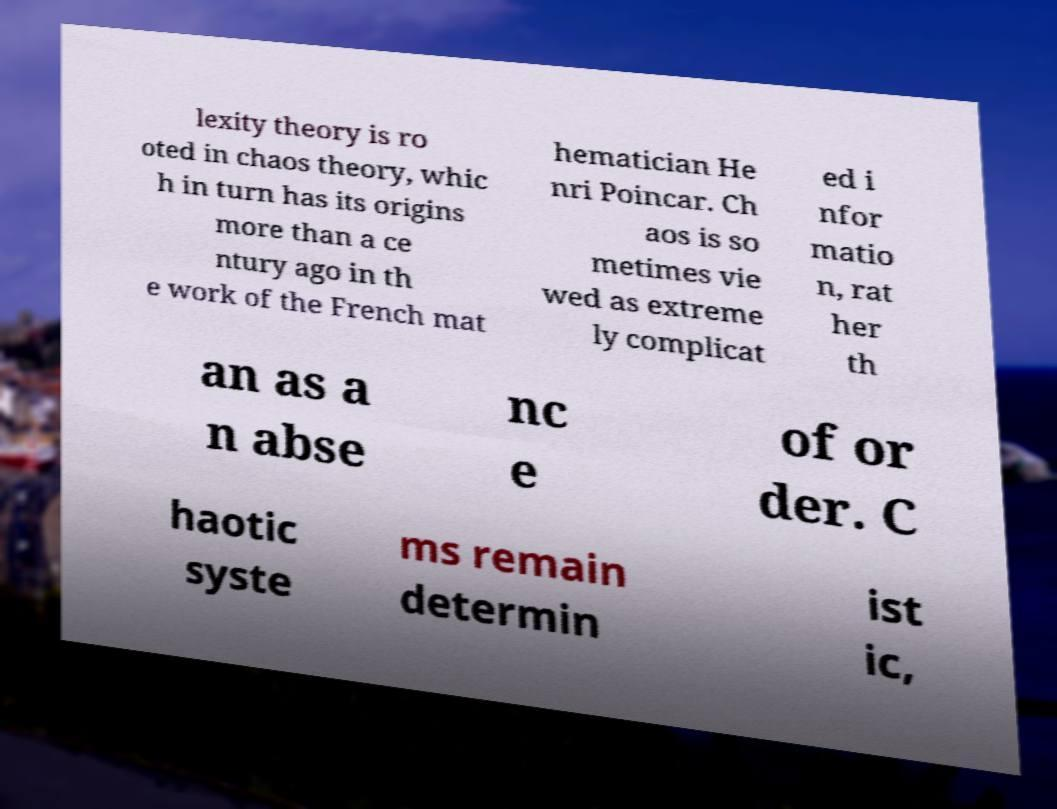Please identify and transcribe the text found in this image. lexity theory is ro oted in chaos theory, whic h in turn has its origins more than a ce ntury ago in th e work of the French mat hematician He nri Poincar. Ch aos is so metimes vie wed as extreme ly complicat ed i nfor matio n, rat her th an as a n abse nc e of or der. C haotic syste ms remain determin ist ic, 